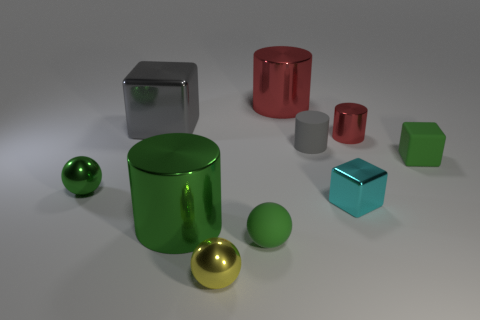Is the color of the small rubber cylinder the same as the large metallic cube?
Your answer should be very brief. Yes. There is a red thing that is the same size as the cyan object; what is it made of?
Your answer should be compact. Metal. Is the large cube made of the same material as the big red object?
Provide a short and direct response. Yes. How many objects are small blue cylinders or large metallic objects?
Provide a short and direct response. 3. The large gray shiny thing that is behind the small green cube has what shape?
Give a very brief answer. Cube. There is another sphere that is made of the same material as the yellow sphere; what is its color?
Your answer should be very brief. Green. What is the material of the small cyan object that is the same shape as the large gray shiny thing?
Your answer should be compact. Metal. The big red thing has what shape?
Provide a succinct answer. Cylinder. There is a green object that is on the right side of the yellow thing and in front of the cyan metallic thing; what material is it?
Your answer should be very brief. Rubber. What is the shape of the gray object that is the same material as the green block?
Give a very brief answer. Cylinder. 